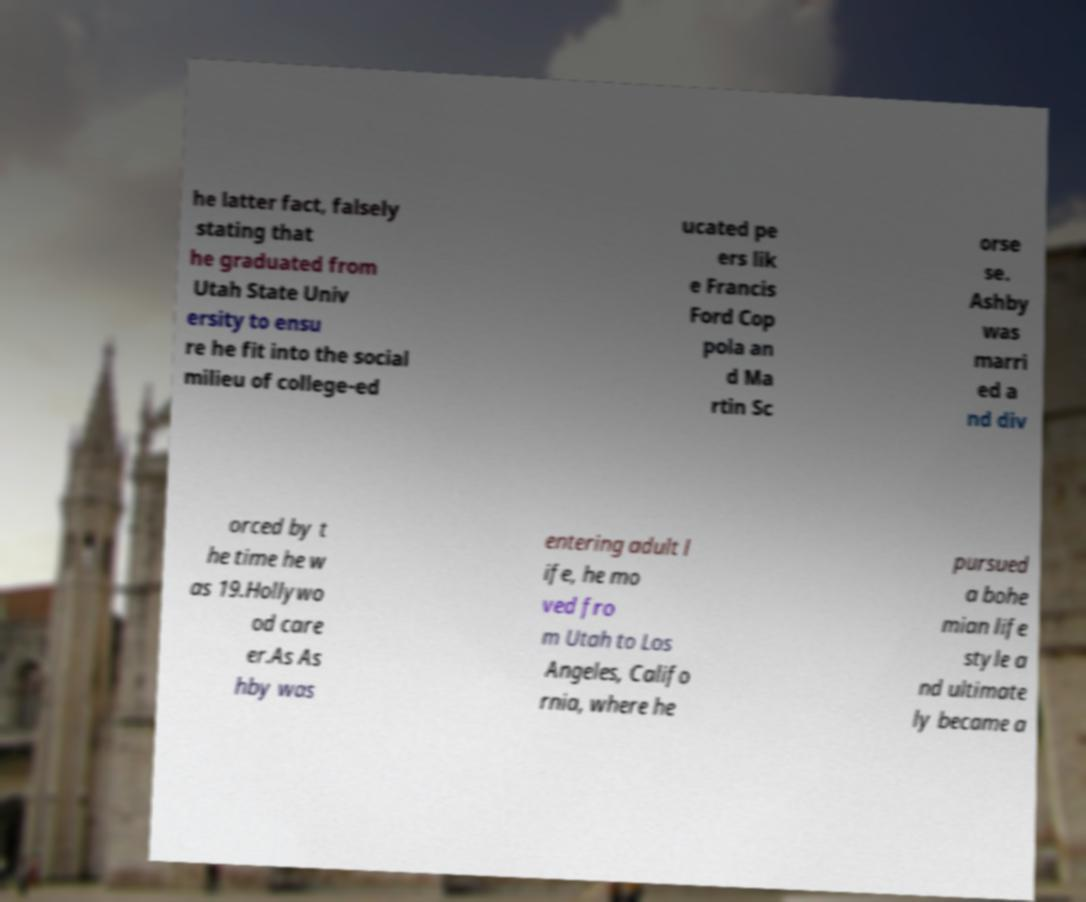Please read and relay the text visible in this image. What does it say? he latter fact, falsely stating that he graduated from Utah State Univ ersity to ensu re he fit into the social milieu of college-ed ucated pe ers lik e Francis Ford Cop pola an d Ma rtin Sc orse se. Ashby was marri ed a nd div orced by t he time he w as 19.Hollywo od care er.As As hby was entering adult l ife, he mo ved fro m Utah to Los Angeles, Califo rnia, where he pursued a bohe mian life style a nd ultimate ly became a 